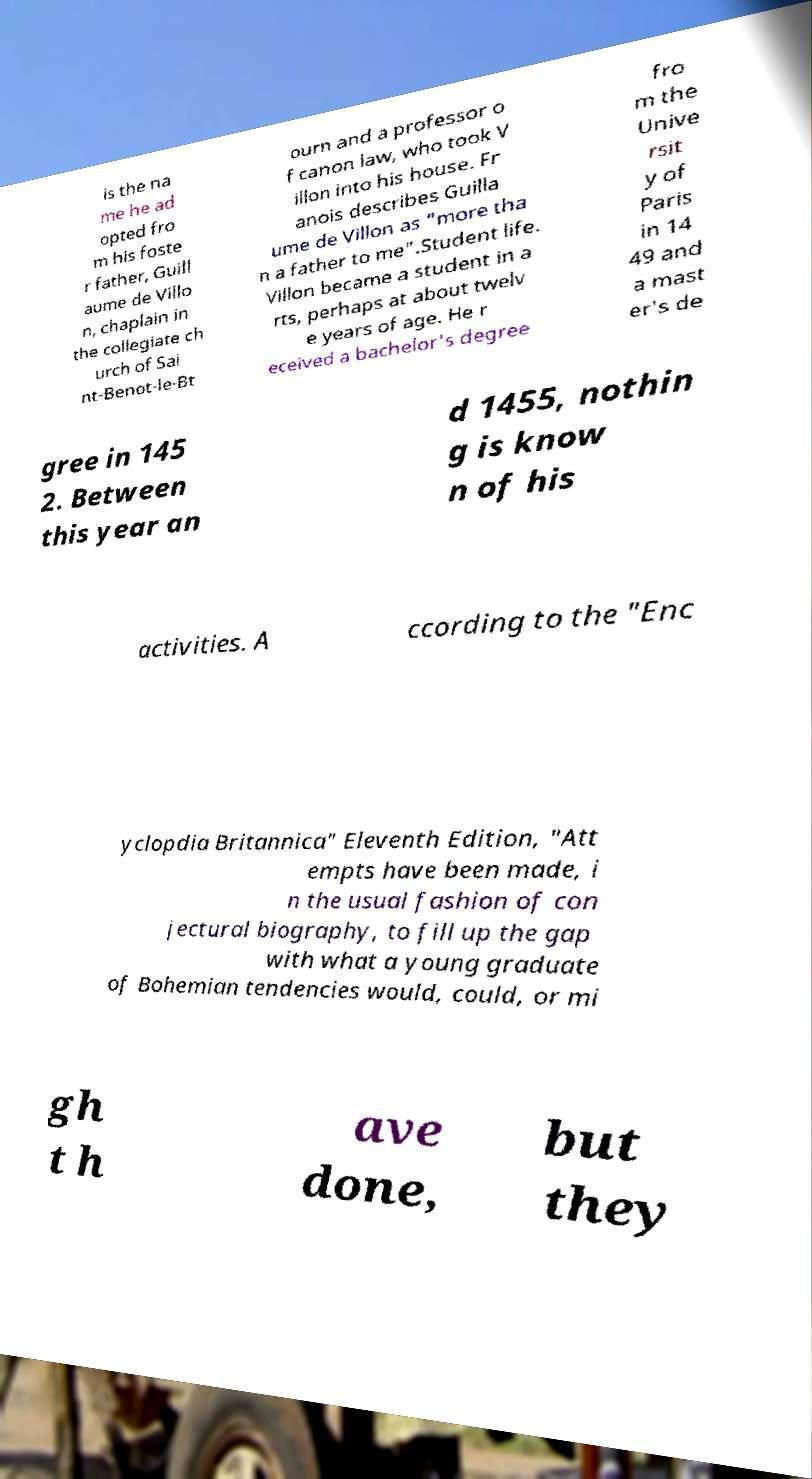There's text embedded in this image that I need extracted. Can you transcribe it verbatim? is the na me he ad opted fro m his foste r father, Guill aume de Villo n, chaplain in the collegiate ch urch of Sai nt-Benot-le-Bt ourn and a professor o f canon law, who took V illon into his house. Fr anois describes Guilla ume de Villon as "more tha n a father to me".Student life. Villon became a student in a rts, perhaps at about twelv e years of age. He r eceived a bachelor's degree fro m the Unive rsit y of Paris in 14 49 and a mast er's de gree in 145 2. Between this year an d 1455, nothin g is know n of his activities. A ccording to the "Enc yclopdia Britannica" Eleventh Edition, "Att empts have been made, i n the usual fashion of con jectural biography, to fill up the gap with what a young graduate of Bohemian tendencies would, could, or mi gh t h ave done, but they 